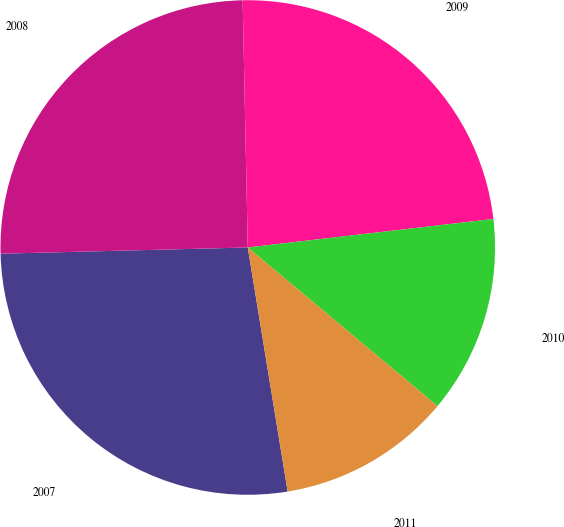Convert chart. <chart><loc_0><loc_0><loc_500><loc_500><pie_chart><fcel>2007<fcel>2008<fcel>2009<fcel>2010<fcel>2011<nl><fcel>27.18%<fcel>25.07%<fcel>23.49%<fcel>12.92%<fcel>11.34%<nl></chart> 